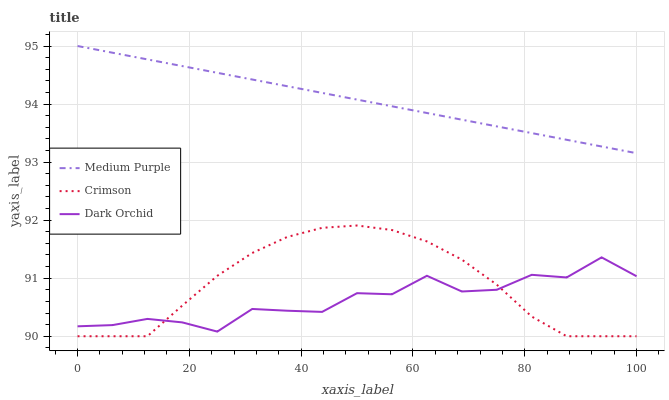Does Crimson have the minimum area under the curve?
Answer yes or no. No. Does Crimson have the maximum area under the curve?
Answer yes or no. No. Is Crimson the smoothest?
Answer yes or no. No. Is Crimson the roughest?
Answer yes or no. No. Does Dark Orchid have the lowest value?
Answer yes or no. No. Does Crimson have the highest value?
Answer yes or no. No. Is Crimson less than Medium Purple?
Answer yes or no. Yes. Is Medium Purple greater than Crimson?
Answer yes or no. Yes. Does Crimson intersect Medium Purple?
Answer yes or no. No. 